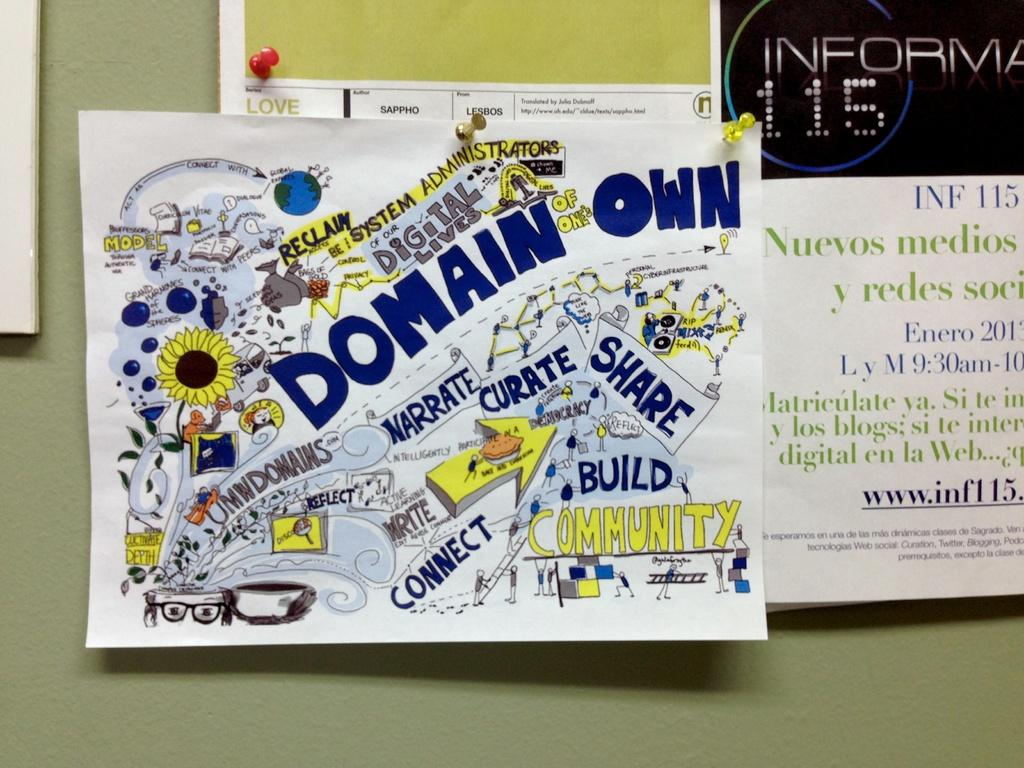<image>
Render a clear and concise summary of the photo. A hand-drawn poster features the words narrate, curate, and share. 